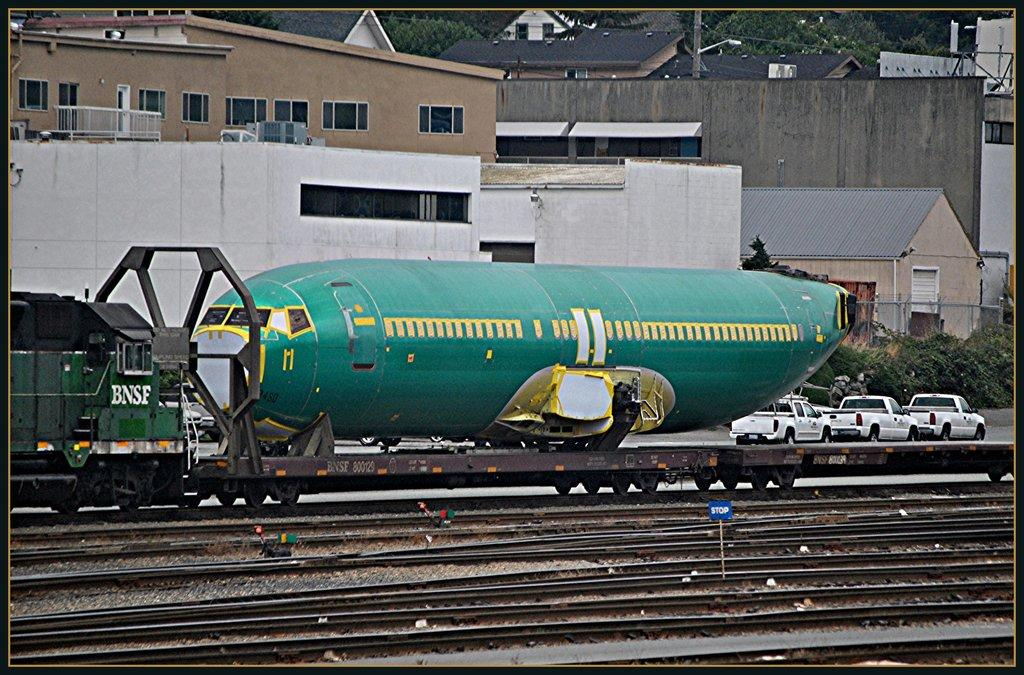<image>
Share a concise interpretation of the image provided. A large green plane sits next railroad tracks and train with the identifier BNSF on the engine. 